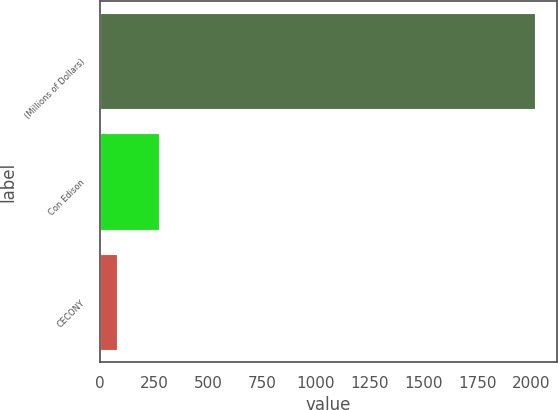Convert chart to OTSL. <chart><loc_0><loc_0><loc_500><loc_500><bar_chart><fcel>(Millions of Dollars)<fcel>Con Edison<fcel>CECONY<nl><fcel>2018<fcel>274.7<fcel>81<nl></chart> 